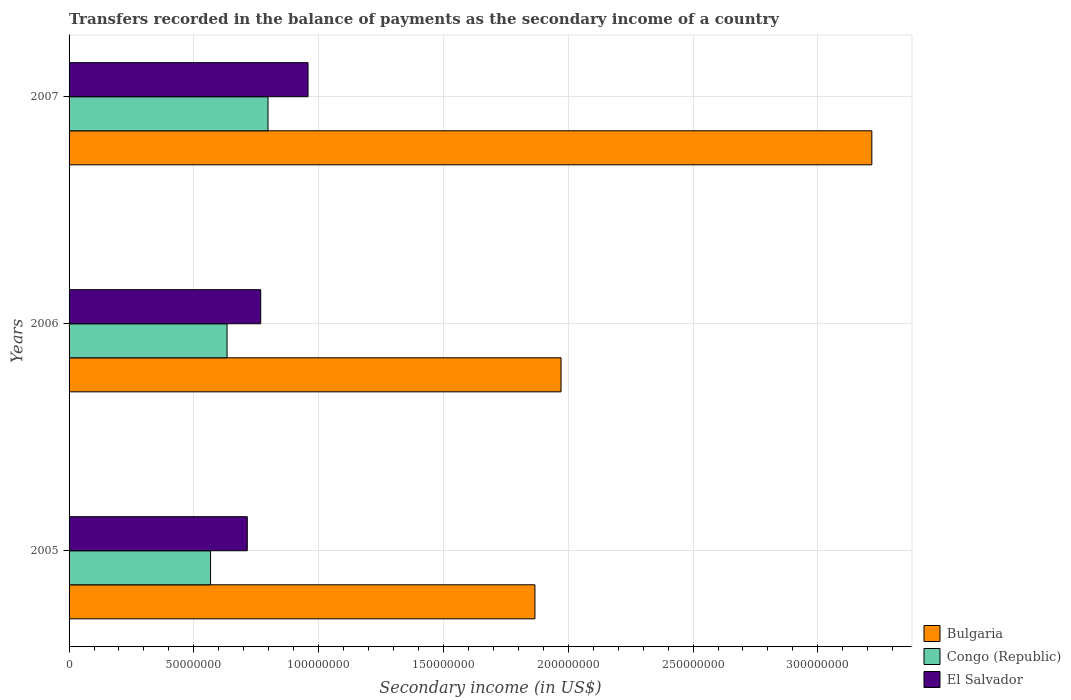How many groups of bars are there?
Provide a short and direct response. 3. Are the number of bars per tick equal to the number of legend labels?
Offer a terse response. Yes. How many bars are there on the 2nd tick from the top?
Your response must be concise. 3. In how many cases, is the number of bars for a given year not equal to the number of legend labels?
Make the answer very short. 0. What is the secondary income of in Congo (Republic) in 2007?
Offer a terse response. 7.97e+07. Across all years, what is the maximum secondary income of in El Salvador?
Offer a terse response. 9.57e+07. Across all years, what is the minimum secondary income of in Congo (Republic)?
Ensure brevity in your answer.  5.67e+07. What is the total secondary income of in Congo (Republic) in the graph?
Provide a succinct answer. 2.00e+08. What is the difference between the secondary income of in El Salvador in 2005 and that in 2007?
Ensure brevity in your answer.  -2.43e+07. What is the difference between the secondary income of in El Salvador in 2006 and the secondary income of in Bulgaria in 2005?
Your answer should be very brief. -1.10e+08. What is the average secondary income of in Congo (Republic) per year?
Offer a very short reply. 6.66e+07. In the year 2006, what is the difference between the secondary income of in El Salvador and secondary income of in Bulgaria?
Make the answer very short. -1.20e+08. What is the ratio of the secondary income of in El Salvador in 2005 to that in 2006?
Your answer should be compact. 0.93. Is the secondary income of in El Salvador in 2006 less than that in 2007?
Provide a succinct answer. Yes. Is the difference between the secondary income of in El Salvador in 2006 and 2007 greater than the difference between the secondary income of in Bulgaria in 2006 and 2007?
Provide a succinct answer. Yes. What is the difference between the highest and the second highest secondary income of in El Salvador?
Ensure brevity in your answer.  1.90e+07. What is the difference between the highest and the lowest secondary income of in El Salvador?
Your response must be concise. 2.43e+07. In how many years, is the secondary income of in Bulgaria greater than the average secondary income of in Bulgaria taken over all years?
Your answer should be very brief. 1. What does the 2nd bar from the top in 2005 represents?
Provide a succinct answer. Congo (Republic). What does the 1st bar from the bottom in 2005 represents?
Offer a terse response. Bulgaria. Is it the case that in every year, the sum of the secondary income of in Bulgaria and secondary income of in El Salvador is greater than the secondary income of in Congo (Republic)?
Provide a short and direct response. Yes. How many years are there in the graph?
Give a very brief answer. 3. What is the difference between two consecutive major ticks on the X-axis?
Your answer should be very brief. 5.00e+07. Are the values on the major ticks of X-axis written in scientific E-notation?
Give a very brief answer. No. Does the graph contain any zero values?
Your answer should be very brief. No. Does the graph contain grids?
Your answer should be compact. Yes. How are the legend labels stacked?
Your answer should be compact. Vertical. What is the title of the graph?
Keep it short and to the point. Transfers recorded in the balance of payments as the secondary income of a country. What is the label or title of the X-axis?
Offer a very short reply. Secondary income (in US$). What is the label or title of the Y-axis?
Ensure brevity in your answer.  Years. What is the Secondary income (in US$) in Bulgaria in 2005?
Provide a succinct answer. 1.87e+08. What is the Secondary income (in US$) of Congo (Republic) in 2005?
Provide a succinct answer. 5.67e+07. What is the Secondary income (in US$) of El Salvador in 2005?
Make the answer very short. 7.14e+07. What is the Secondary income (in US$) in Bulgaria in 2006?
Your answer should be very brief. 1.97e+08. What is the Secondary income (in US$) of Congo (Republic) in 2006?
Your answer should be compact. 6.33e+07. What is the Secondary income (in US$) of El Salvador in 2006?
Provide a short and direct response. 7.68e+07. What is the Secondary income (in US$) in Bulgaria in 2007?
Your answer should be compact. 3.22e+08. What is the Secondary income (in US$) in Congo (Republic) in 2007?
Provide a short and direct response. 7.97e+07. What is the Secondary income (in US$) of El Salvador in 2007?
Keep it short and to the point. 9.57e+07. Across all years, what is the maximum Secondary income (in US$) in Bulgaria?
Your answer should be very brief. 3.22e+08. Across all years, what is the maximum Secondary income (in US$) of Congo (Republic)?
Offer a very short reply. 7.97e+07. Across all years, what is the maximum Secondary income (in US$) of El Salvador?
Offer a terse response. 9.57e+07. Across all years, what is the minimum Secondary income (in US$) of Bulgaria?
Your response must be concise. 1.87e+08. Across all years, what is the minimum Secondary income (in US$) of Congo (Republic)?
Offer a very short reply. 5.67e+07. Across all years, what is the minimum Secondary income (in US$) of El Salvador?
Ensure brevity in your answer.  7.14e+07. What is the total Secondary income (in US$) of Bulgaria in the graph?
Ensure brevity in your answer.  7.05e+08. What is the total Secondary income (in US$) of Congo (Republic) in the graph?
Keep it short and to the point. 2.00e+08. What is the total Secondary income (in US$) in El Salvador in the graph?
Your response must be concise. 2.44e+08. What is the difference between the Secondary income (in US$) of Bulgaria in 2005 and that in 2006?
Keep it short and to the point. -1.05e+07. What is the difference between the Secondary income (in US$) in Congo (Republic) in 2005 and that in 2006?
Your answer should be very brief. -6.62e+06. What is the difference between the Secondary income (in US$) of El Salvador in 2005 and that in 2006?
Ensure brevity in your answer.  -5.38e+06. What is the difference between the Secondary income (in US$) of Bulgaria in 2005 and that in 2007?
Offer a very short reply. -1.35e+08. What is the difference between the Secondary income (in US$) of Congo (Republic) in 2005 and that in 2007?
Your answer should be very brief. -2.30e+07. What is the difference between the Secondary income (in US$) of El Salvador in 2005 and that in 2007?
Keep it short and to the point. -2.43e+07. What is the difference between the Secondary income (in US$) in Bulgaria in 2006 and that in 2007?
Your answer should be very brief. -1.25e+08. What is the difference between the Secondary income (in US$) of Congo (Republic) in 2006 and that in 2007?
Give a very brief answer. -1.64e+07. What is the difference between the Secondary income (in US$) in El Salvador in 2006 and that in 2007?
Make the answer very short. -1.90e+07. What is the difference between the Secondary income (in US$) in Bulgaria in 2005 and the Secondary income (in US$) in Congo (Republic) in 2006?
Offer a very short reply. 1.23e+08. What is the difference between the Secondary income (in US$) in Bulgaria in 2005 and the Secondary income (in US$) in El Salvador in 2006?
Offer a terse response. 1.10e+08. What is the difference between the Secondary income (in US$) in Congo (Republic) in 2005 and the Secondary income (in US$) in El Salvador in 2006?
Ensure brevity in your answer.  -2.01e+07. What is the difference between the Secondary income (in US$) of Bulgaria in 2005 and the Secondary income (in US$) of Congo (Republic) in 2007?
Keep it short and to the point. 1.07e+08. What is the difference between the Secondary income (in US$) of Bulgaria in 2005 and the Secondary income (in US$) of El Salvador in 2007?
Make the answer very short. 9.09e+07. What is the difference between the Secondary income (in US$) in Congo (Republic) in 2005 and the Secondary income (in US$) in El Salvador in 2007?
Your response must be concise. -3.91e+07. What is the difference between the Secondary income (in US$) of Bulgaria in 2006 and the Secondary income (in US$) of Congo (Republic) in 2007?
Provide a short and direct response. 1.17e+08. What is the difference between the Secondary income (in US$) in Bulgaria in 2006 and the Secondary income (in US$) in El Salvador in 2007?
Offer a very short reply. 1.01e+08. What is the difference between the Secondary income (in US$) of Congo (Republic) in 2006 and the Secondary income (in US$) of El Salvador in 2007?
Provide a succinct answer. -3.24e+07. What is the average Secondary income (in US$) of Bulgaria per year?
Ensure brevity in your answer.  2.35e+08. What is the average Secondary income (in US$) of Congo (Republic) per year?
Your answer should be very brief. 6.66e+07. What is the average Secondary income (in US$) in El Salvador per year?
Ensure brevity in your answer.  8.13e+07. In the year 2005, what is the difference between the Secondary income (in US$) of Bulgaria and Secondary income (in US$) of Congo (Republic)?
Offer a very short reply. 1.30e+08. In the year 2005, what is the difference between the Secondary income (in US$) in Bulgaria and Secondary income (in US$) in El Salvador?
Provide a succinct answer. 1.15e+08. In the year 2005, what is the difference between the Secondary income (in US$) in Congo (Republic) and Secondary income (in US$) in El Salvador?
Ensure brevity in your answer.  -1.47e+07. In the year 2006, what is the difference between the Secondary income (in US$) in Bulgaria and Secondary income (in US$) in Congo (Republic)?
Your answer should be very brief. 1.34e+08. In the year 2006, what is the difference between the Secondary income (in US$) of Bulgaria and Secondary income (in US$) of El Salvador?
Your answer should be very brief. 1.20e+08. In the year 2006, what is the difference between the Secondary income (in US$) in Congo (Republic) and Secondary income (in US$) in El Salvador?
Offer a very short reply. -1.35e+07. In the year 2007, what is the difference between the Secondary income (in US$) in Bulgaria and Secondary income (in US$) in Congo (Republic)?
Your response must be concise. 2.42e+08. In the year 2007, what is the difference between the Secondary income (in US$) of Bulgaria and Secondary income (in US$) of El Salvador?
Your answer should be compact. 2.26e+08. In the year 2007, what is the difference between the Secondary income (in US$) of Congo (Republic) and Secondary income (in US$) of El Salvador?
Provide a succinct answer. -1.60e+07. What is the ratio of the Secondary income (in US$) in Bulgaria in 2005 to that in 2006?
Keep it short and to the point. 0.95. What is the ratio of the Secondary income (in US$) in Congo (Republic) in 2005 to that in 2006?
Your response must be concise. 0.9. What is the ratio of the Secondary income (in US$) in El Salvador in 2005 to that in 2006?
Provide a succinct answer. 0.93. What is the ratio of the Secondary income (in US$) in Bulgaria in 2005 to that in 2007?
Provide a succinct answer. 0.58. What is the ratio of the Secondary income (in US$) of Congo (Republic) in 2005 to that in 2007?
Offer a very short reply. 0.71. What is the ratio of the Secondary income (in US$) of El Salvador in 2005 to that in 2007?
Give a very brief answer. 0.75. What is the ratio of the Secondary income (in US$) in Bulgaria in 2006 to that in 2007?
Provide a succinct answer. 0.61. What is the ratio of the Secondary income (in US$) of Congo (Republic) in 2006 to that in 2007?
Your answer should be compact. 0.79. What is the ratio of the Secondary income (in US$) in El Salvador in 2006 to that in 2007?
Offer a very short reply. 0.8. What is the difference between the highest and the second highest Secondary income (in US$) of Bulgaria?
Offer a very short reply. 1.25e+08. What is the difference between the highest and the second highest Secondary income (in US$) in Congo (Republic)?
Keep it short and to the point. 1.64e+07. What is the difference between the highest and the second highest Secondary income (in US$) of El Salvador?
Your response must be concise. 1.90e+07. What is the difference between the highest and the lowest Secondary income (in US$) of Bulgaria?
Provide a succinct answer. 1.35e+08. What is the difference between the highest and the lowest Secondary income (in US$) in Congo (Republic)?
Your answer should be compact. 2.30e+07. What is the difference between the highest and the lowest Secondary income (in US$) in El Salvador?
Ensure brevity in your answer.  2.43e+07. 